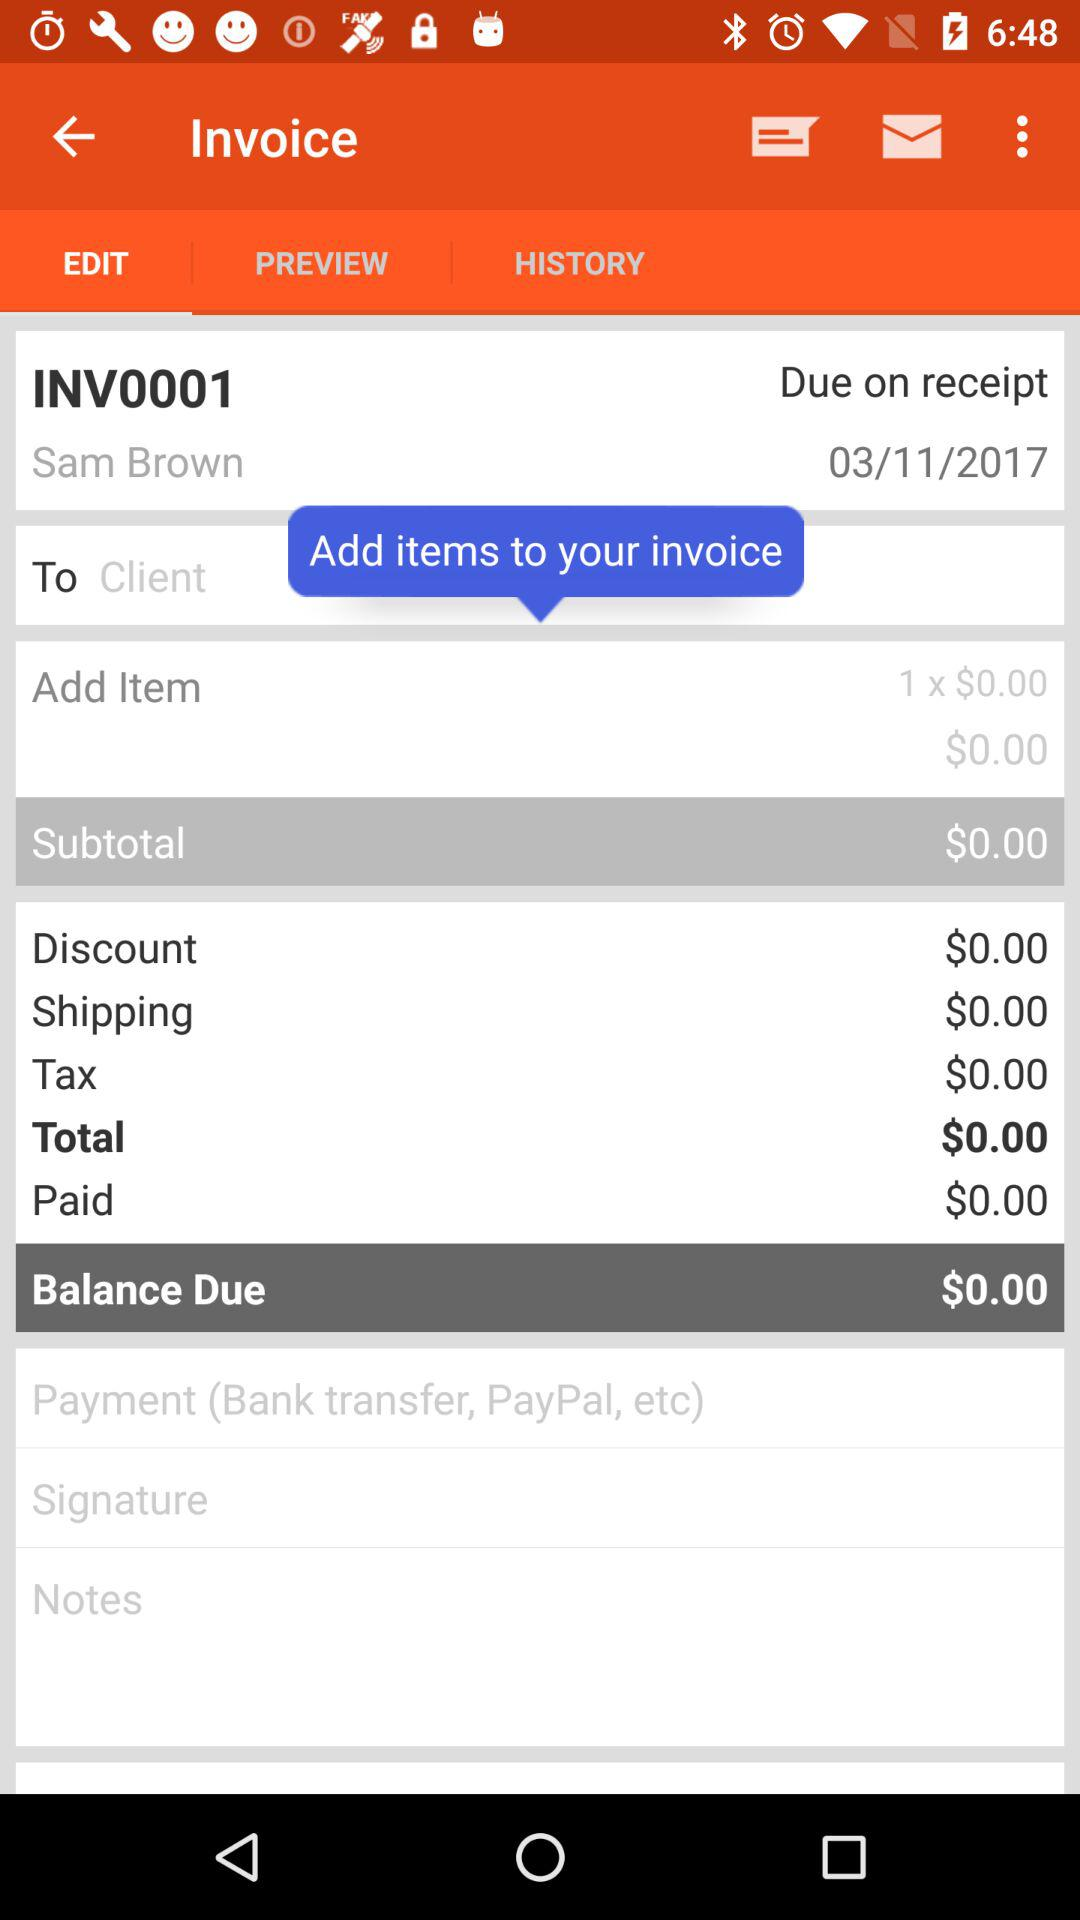What is the name on the invoice? The name on the invoice is Sam Brown. 